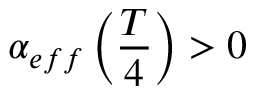Convert formula to latex. <formula><loc_0><loc_0><loc_500><loc_500>\alpha _ { e f f } \left ( \frac { T } { 4 } \right ) > 0</formula> 